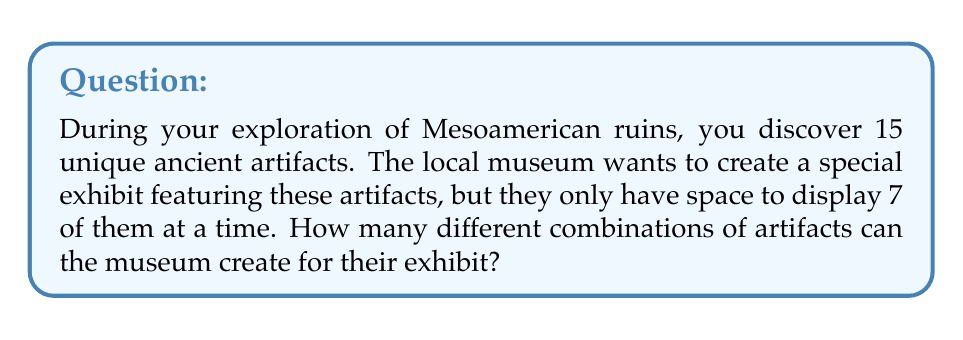Teach me how to tackle this problem. To solve this problem, we need to use the combination formula. We are selecting 7 artifacts out of 15, where the order doesn't matter (as it's just about which artifacts are displayed, not their arrangement).

The formula for combinations is:

$$C(n,r) = \frac{n!}{r!(n-r)!}$$

Where:
$n$ is the total number of items to choose from (in this case, 15 artifacts)
$r$ is the number of items being chosen (in this case, 7 artifacts)

Let's substitute these values:

$$C(15,7) = \frac{15!}{7!(15-7)!} = \frac{15!}{7!(8)!}$$

Now, let's calculate this step-by-step:

1) $15! = 1,307,674,368,000$
2) $7! = 5,040$
3) $8! = 40,320$

Substituting these values:

$$\frac{1,307,674,368,000}{5,040 \times 40,320}$$

4) $5,040 \times 40,320 = 203,212,800$

5) $\frac{1,307,674,368,000}{203,212,800} = 6,435$

Therefore, the museum can create 6,435 different combinations of artifacts for their exhibit.
Answer: 6,435 combinations 